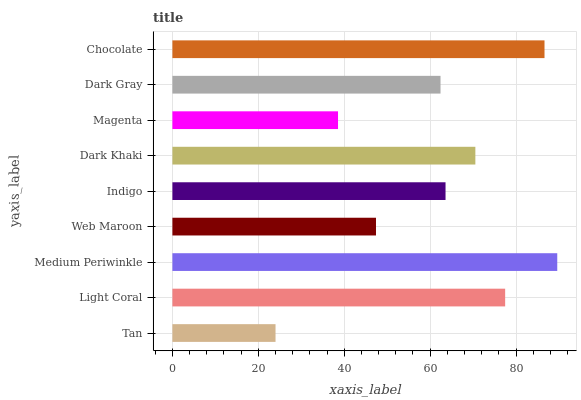Is Tan the minimum?
Answer yes or no. Yes. Is Medium Periwinkle the maximum?
Answer yes or no. Yes. Is Light Coral the minimum?
Answer yes or no. No. Is Light Coral the maximum?
Answer yes or no. No. Is Light Coral greater than Tan?
Answer yes or no. Yes. Is Tan less than Light Coral?
Answer yes or no. Yes. Is Tan greater than Light Coral?
Answer yes or no. No. Is Light Coral less than Tan?
Answer yes or no. No. Is Indigo the high median?
Answer yes or no. Yes. Is Indigo the low median?
Answer yes or no. Yes. Is Light Coral the high median?
Answer yes or no. No. Is Chocolate the low median?
Answer yes or no. No. 